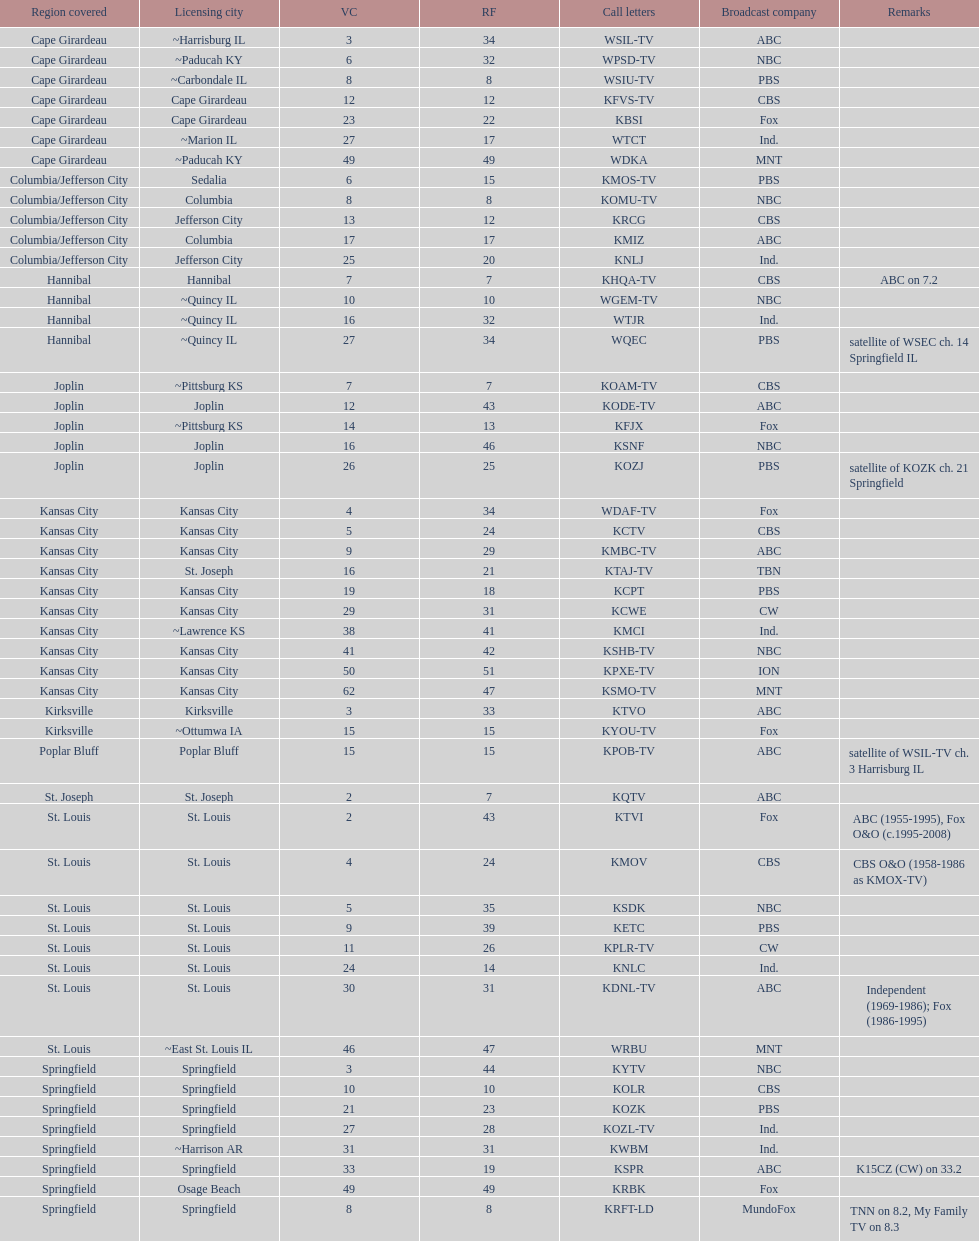What is the total number of stations under the cbs network? 7. 